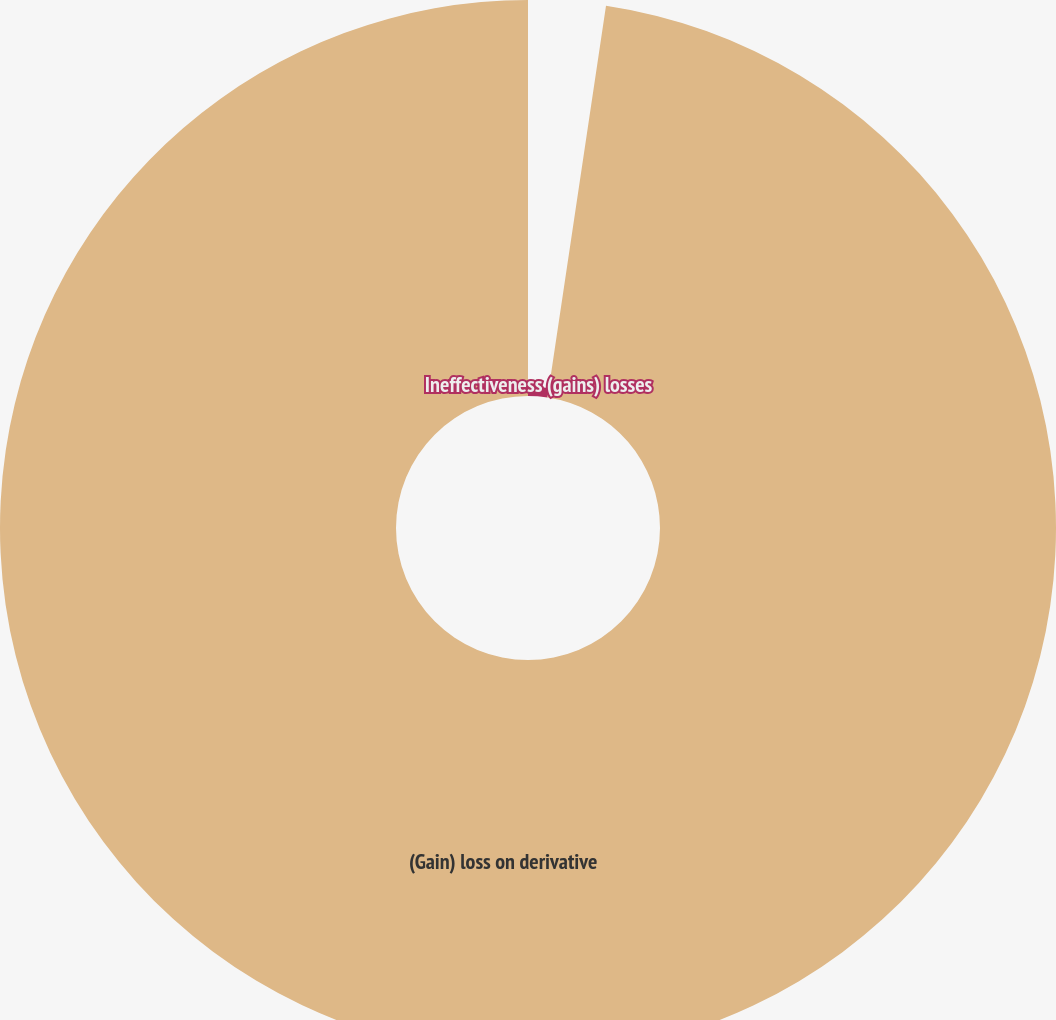<chart> <loc_0><loc_0><loc_500><loc_500><pie_chart><fcel>Ineffectiveness (gains) losses<fcel>(Gain) loss on derivative<nl><fcel>2.36%<fcel>97.64%<nl></chart> 